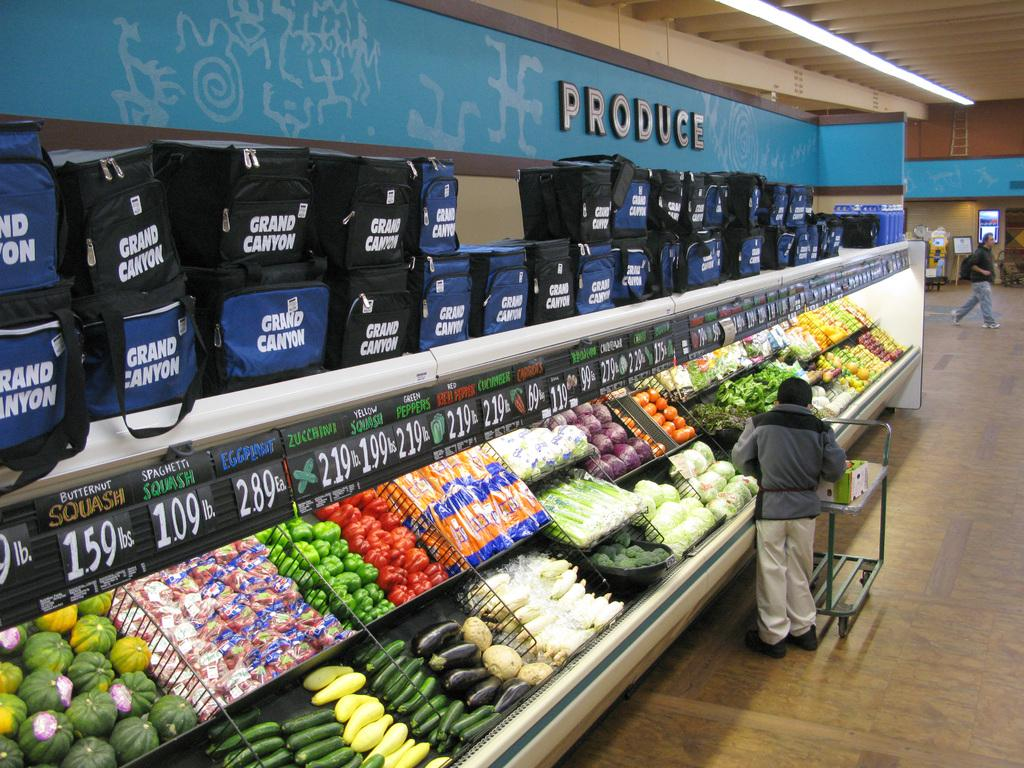Provide a one-sentence caption for the provided image. the produce section of a grocery store with a man in front of it. 